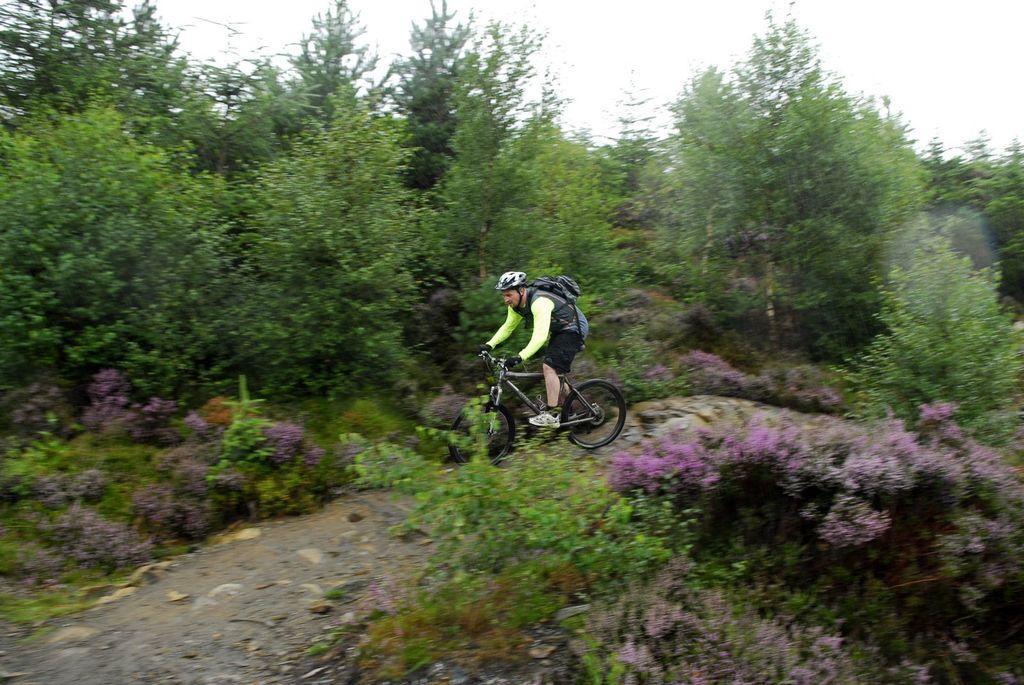How would you summarize this image in a sentence or two? There is a man riding bicycle and wore bag and helmet. We can see trees and plants. In the background we can see sky. 